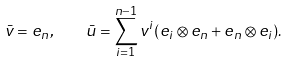<formula> <loc_0><loc_0><loc_500><loc_500>\bar { v } = e _ { n } , \quad \bar { u } = \sum _ { i = 1 } ^ { n - 1 } v ^ { i } ( e _ { i } \otimes e _ { n } + e _ { n } \otimes e _ { i } ) .</formula> 